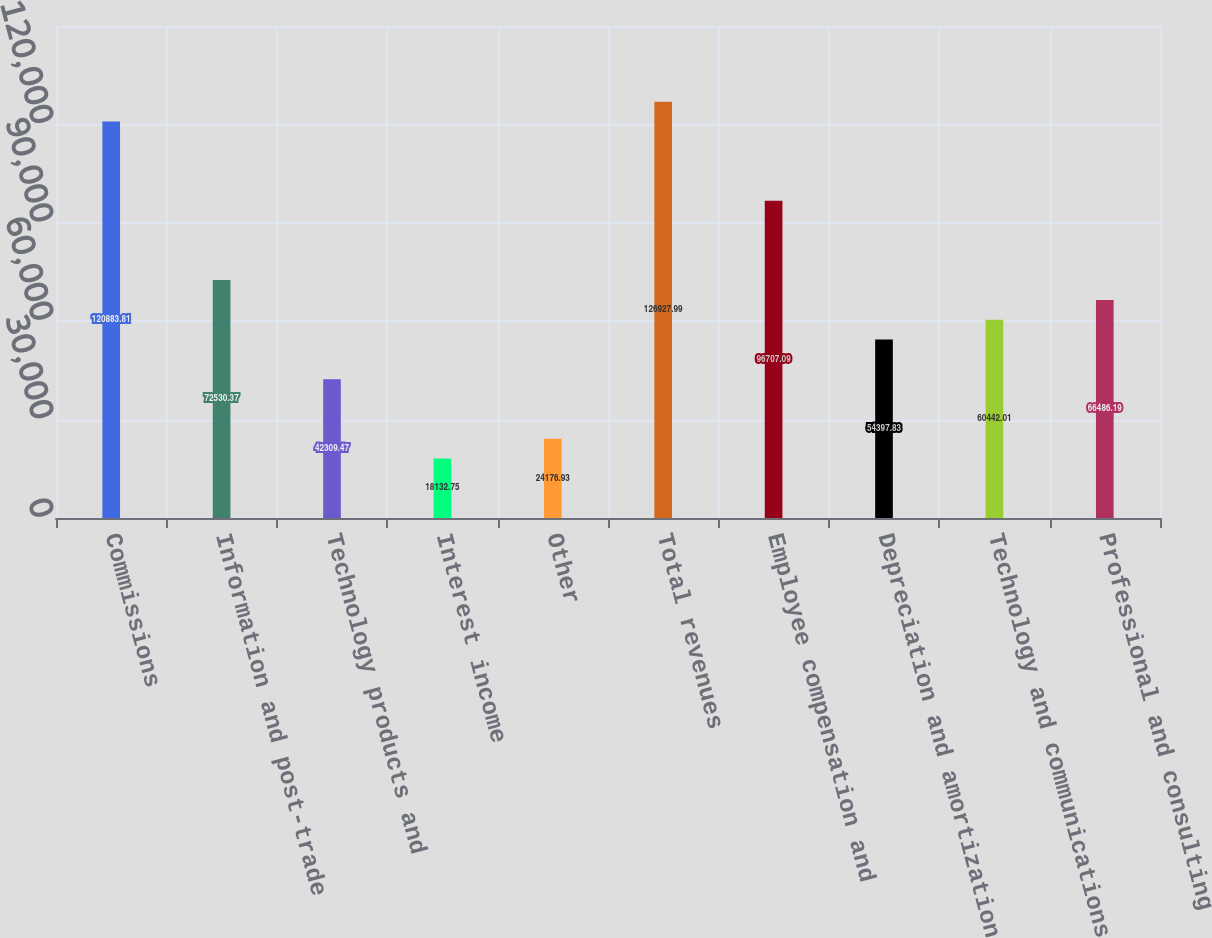Convert chart. <chart><loc_0><loc_0><loc_500><loc_500><bar_chart><fcel>Commissions<fcel>Information and post-trade<fcel>Technology products and<fcel>Interest income<fcel>Other<fcel>Total revenues<fcel>Employee compensation and<fcel>Depreciation and amortization<fcel>Technology and communications<fcel>Professional and consulting<nl><fcel>120884<fcel>72530.4<fcel>42309.5<fcel>18132.8<fcel>24176.9<fcel>126928<fcel>96707.1<fcel>54397.8<fcel>60442<fcel>66486.2<nl></chart> 